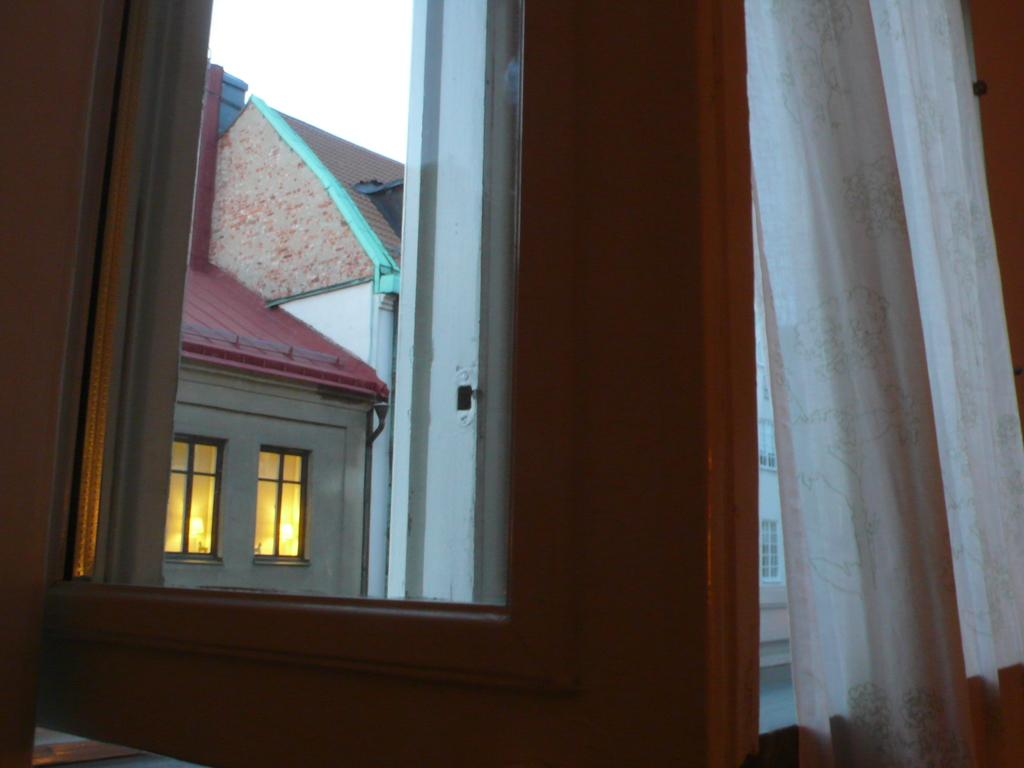What can be seen in the image that provides a view of the outdoors? There is a window in the image. What type of window treatment is present in the image? There is a curtain in white color in the image. What is visible in the background of the image? There is a building in the background of the image. What colors are present on the building? The building has white and red colors. What is visible in the sky in the background of the image? The sky is visible in the background of the image, and it appears to be white in color. How many eggs are visible in the image? There are no eggs present in the image. What type of picture is hanging on the wall in the image? There is no mention of a picture hanging on the wall in the image. 